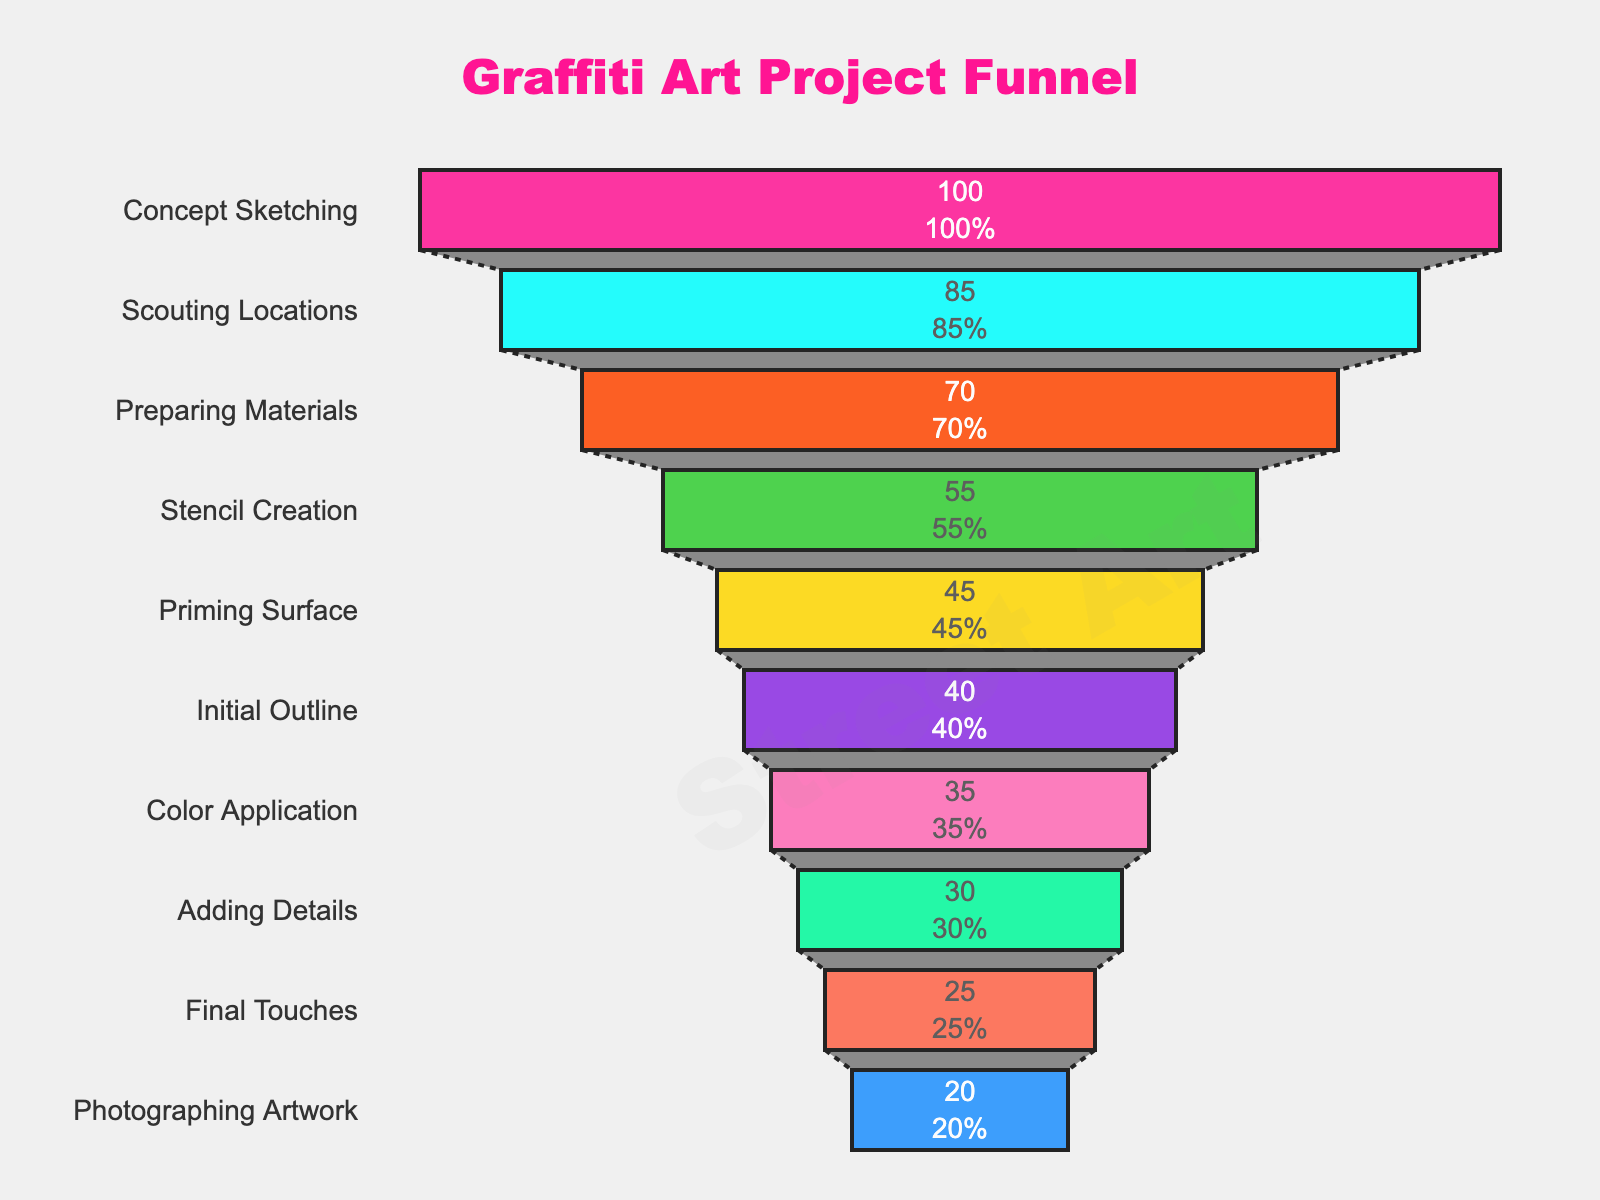What is the title of the funnel chart? The title of the funnel chart is displayed at the top, containing all the relevant descriptive text.
Answer: Graffiti Art Project Funnel What is the stage with the highest number of projects? The highest number of projects is represented by the first stage at the top of the funnel, which has the highest value.
Answer: Concept Sketching How many projects are at the Adding Details stage? The number of projects is marked next to each stage, and you can find the "Adding Details" stage by looking down the funnel.
Answer: 30 Which stage has fewer projects, Priming Surface or Initial Outline? Compare the numbers next to the "Priming Surface" and "Initial Outline" stages to determine which one is lower.
Answer: Priming Surface How does the number of projects reduce from Initial Outline to Final Touches? Subtract the number of projects in "Final Touches" from those in "Initial Outline" to find the reduction. The values are next to each stage.
Answer: 15 What percentage of original projects reach Color Application? The number for "Color Application" divided by the initial number of projects (Concept Sketching), and multiply by 100 to find the percentage.
Answer: 35% How many total stages are there in the graffiti art project funnel? Count all the stages listed from top to bottom in the funnel chart.
Answer: 10 Is the drop-off higher from Concept Sketching to Scouting Locations or from Stencil Creation to Priming Surface? Compare the numerical drop (difference) between the number of projects for each pair of stages.
Answer: Concept Sketching to Scouting Locations Which two consecutive stages have the least drop in the number of projects? Calculate the drop between each pair of consecutive stages and compare to find the smallest drop.
Answer: Initial Outline to Color Application How many projects proceed from Stencil Creation to Photographing Artwork? Identify the number of projects at "Stencil Creation" and compare to the number at "Photographing Artwork" without considering the intermediate stages.
Answer: 20 